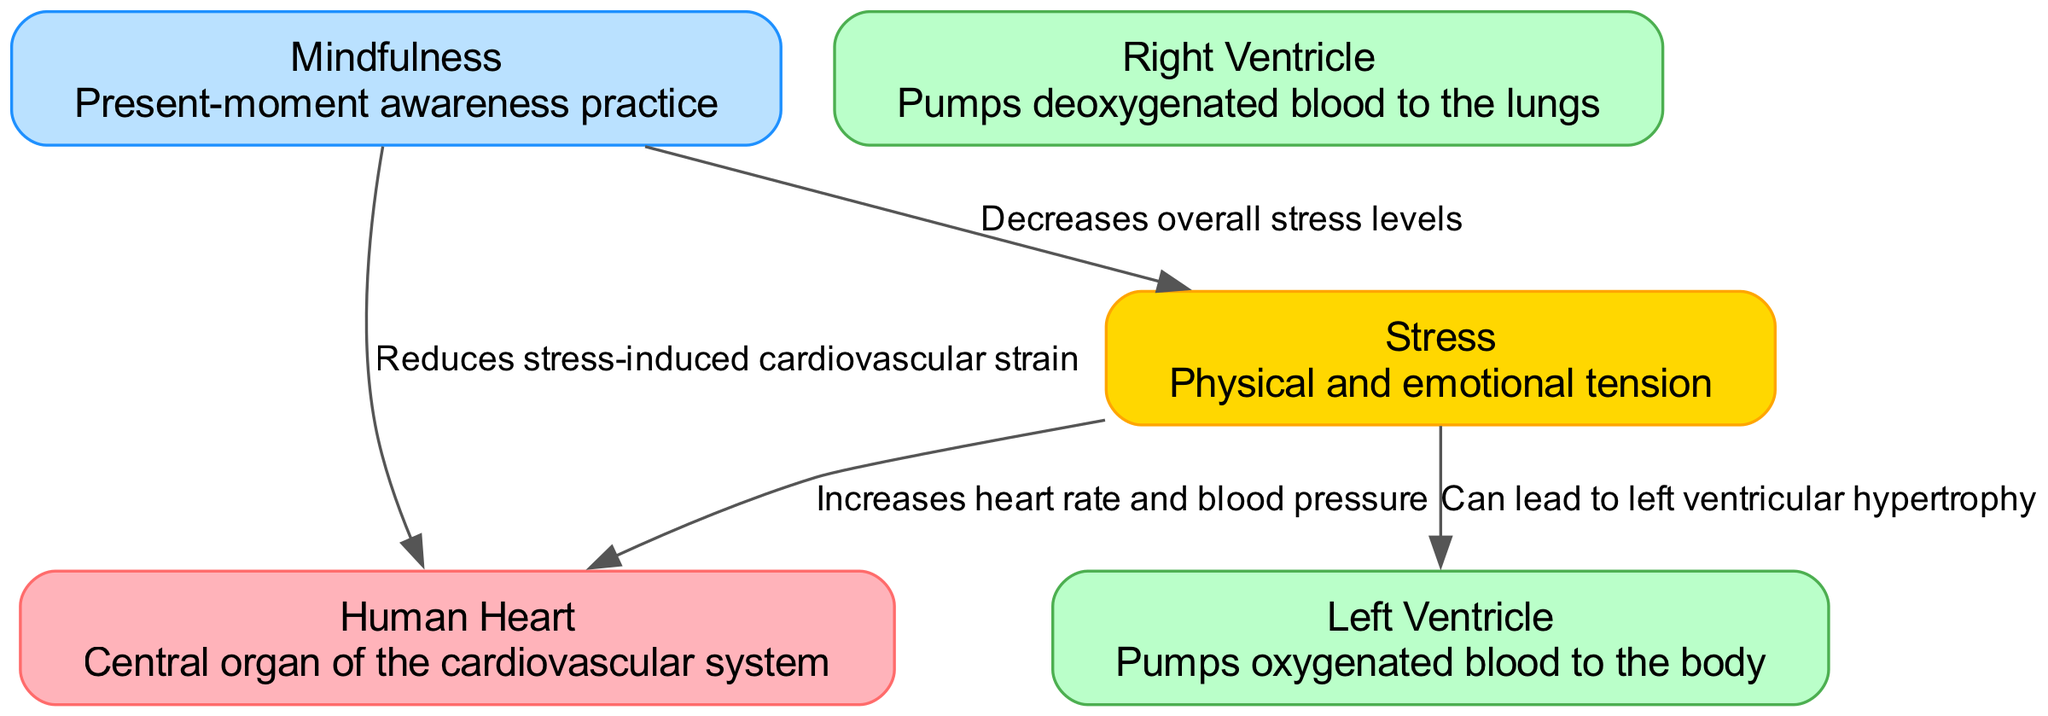What is the central organ of the cardiovascular system? The diagram identifies the central organ as the "Human Heart," which is specifically labeled in the nodes section.
Answer: Human Heart How many nodes are represented in the diagram? By counting the individual nodes listed in the data, there are five nodes: Human Heart, Left Ventricle, Right Ventricle, Stress, and Mindfulness.
Answer: 5 What impact does stress have on the left ventricle? The edge connecting Stress to Left Ventricle indicates that stress "Can lead to left ventricular hypertrophy," which describes a condition of the left ventricle as a result of stress.
Answer: Can lead to left ventricular hypertrophy How does mindfulness affect stress levels? The diagram indicates that mindfulness "Decreases overall stress levels," creating a direct relationship between the node Mindfulness and the node Stress.
Answer: Decreases overall stress levels What effect does stress have on the heart? The diagram shows that stress "Increases heart rate and blood pressure," which indicates a negative impact of stress on the cardiovascular system as represented by the heart.
Answer: Increases heart rate and blood pressure What is the overall effect of mindfulness on cardiovascular strain? The connection from Mindfulness to Heart states that mindfulness "Reduces stress-induced cardiovascular strain," indicating a beneficial impact on heart health.
Answer: Reduces stress-induced cardiovascular strain How many edges are present in the diagram? Counting the edges in the data, there are four connections showing relationships between the nodes.
Answer: 4 What label describes the practice of mindfulness? The description associated with the Mindfulness node states it is a "Present-moment awareness practice," which provides insight into the nature of mindfulness.
Answer: Present-moment awareness practice How does stress relate to cardiovascular health? The diagram outlines multiple ways stress impacts cardiovascular health, including increasing heart rate and blood pressure and potentially affecting the left ventricle, establishing a clear negative relationship between stress and heart health.
Answer: Increases heart rate and blood pressure, can lead to left ventricular hypertrophy 